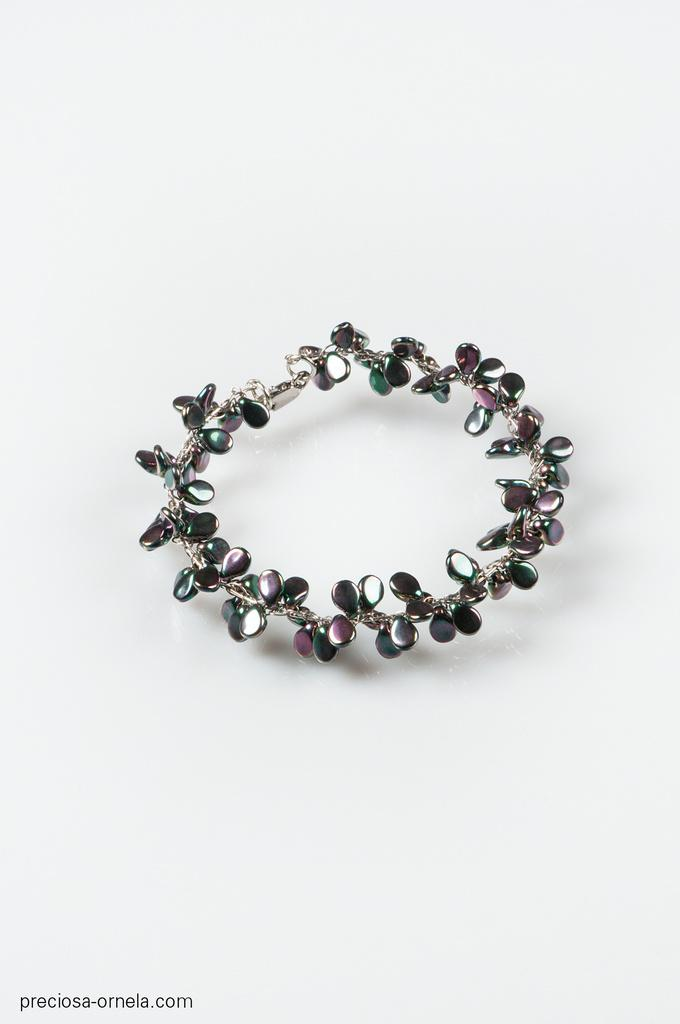What is the main subject in the middle of the image? There is an ornament in the middle of the image. Where is the ornament placed? The ornament is on a surface. Is there any text or marking on the image? Yes, there is a watermark on the bottom left of the image. What color is the background of the image? The background of the image is white. What type of shirt is being worn by the society in the image? There is no shirt or society present in the image; it features an ornament on a surface with a white background and a watermark. 